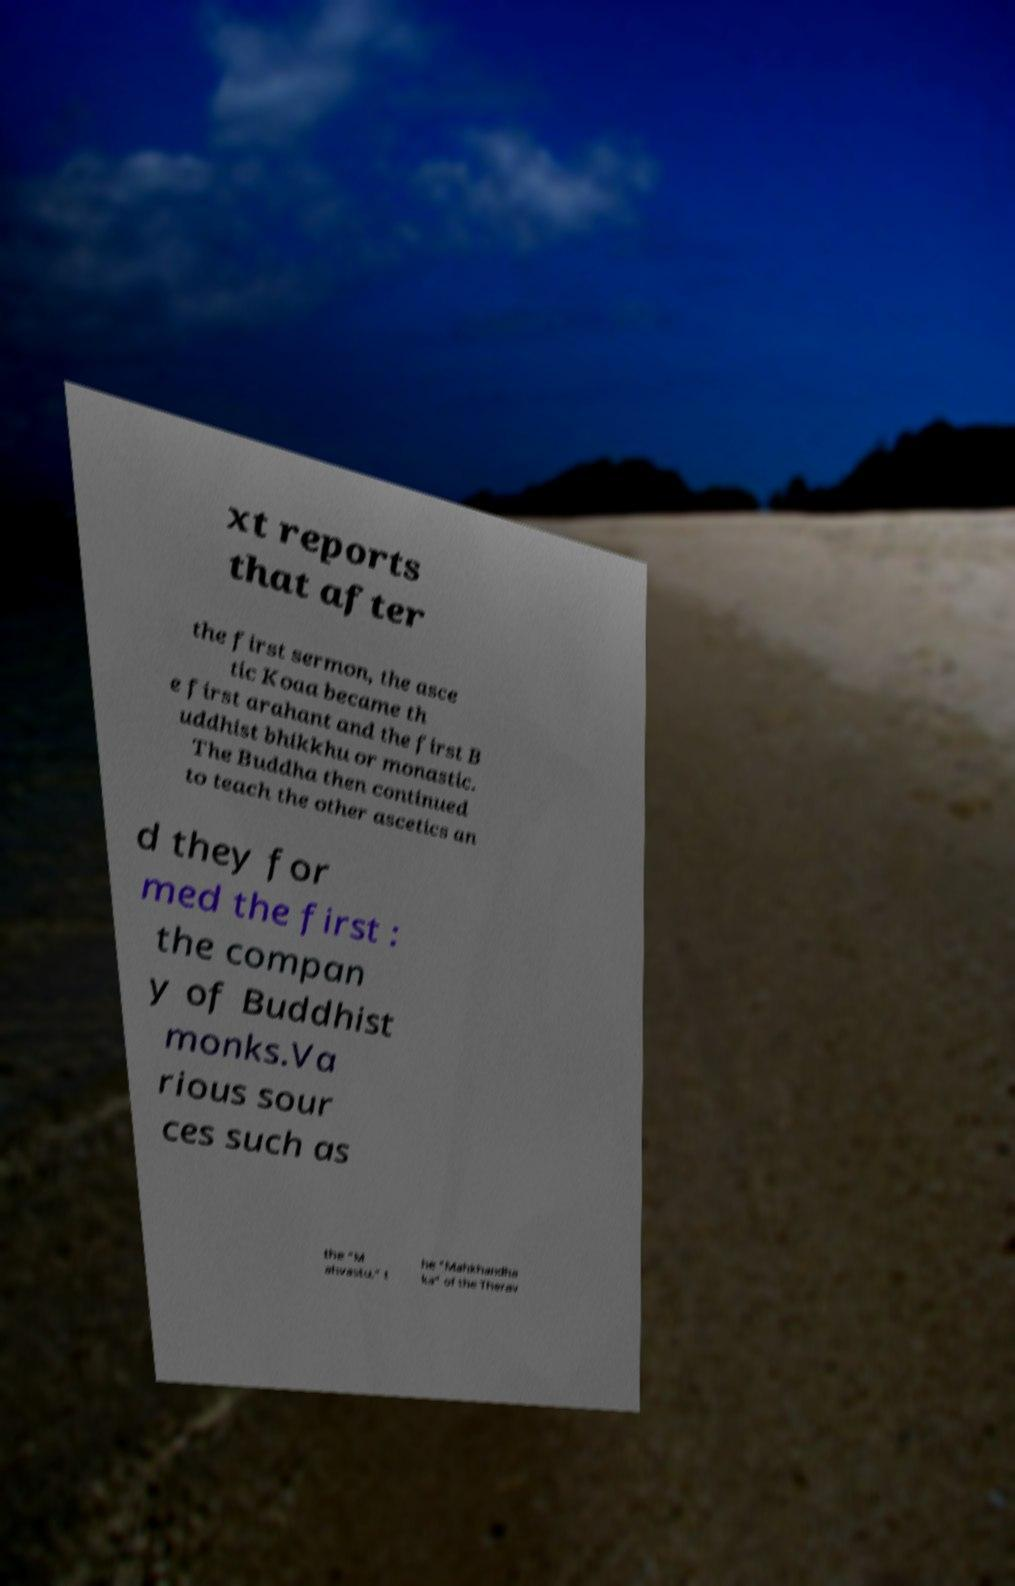I need the written content from this picture converted into text. Can you do that? xt reports that after the first sermon, the asce tic Koaa became th e first arahant and the first B uddhist bhikkhu or monastic. The Buddha then continued to teach the other ascetics an d they for med the first : the compan y of Buddhist monks.Va rious sour ces such as the "M ahvastu," t he "Mahkhandha ka" of the Therav 